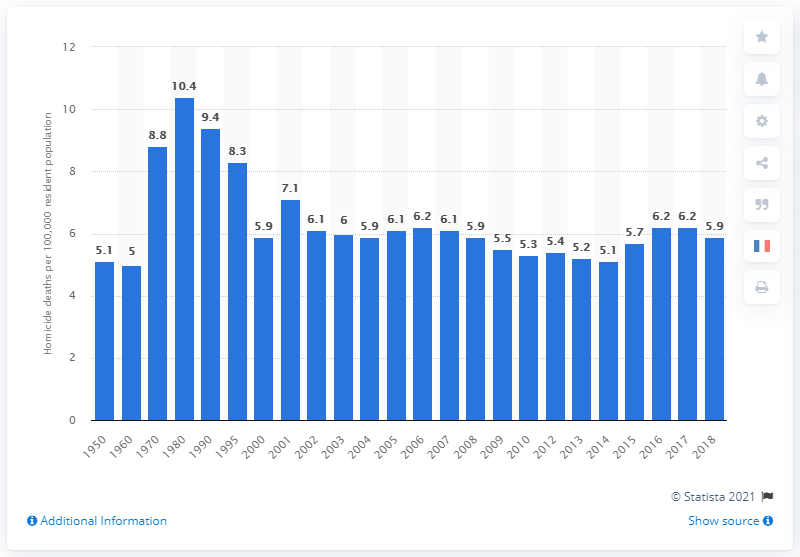Point out several critical features in this image. In 1950, there were 5.1 deaths by homicide per 100,000 of the US population. In 2018, there were 5.9 deaths by homicide per 100,000 population. 